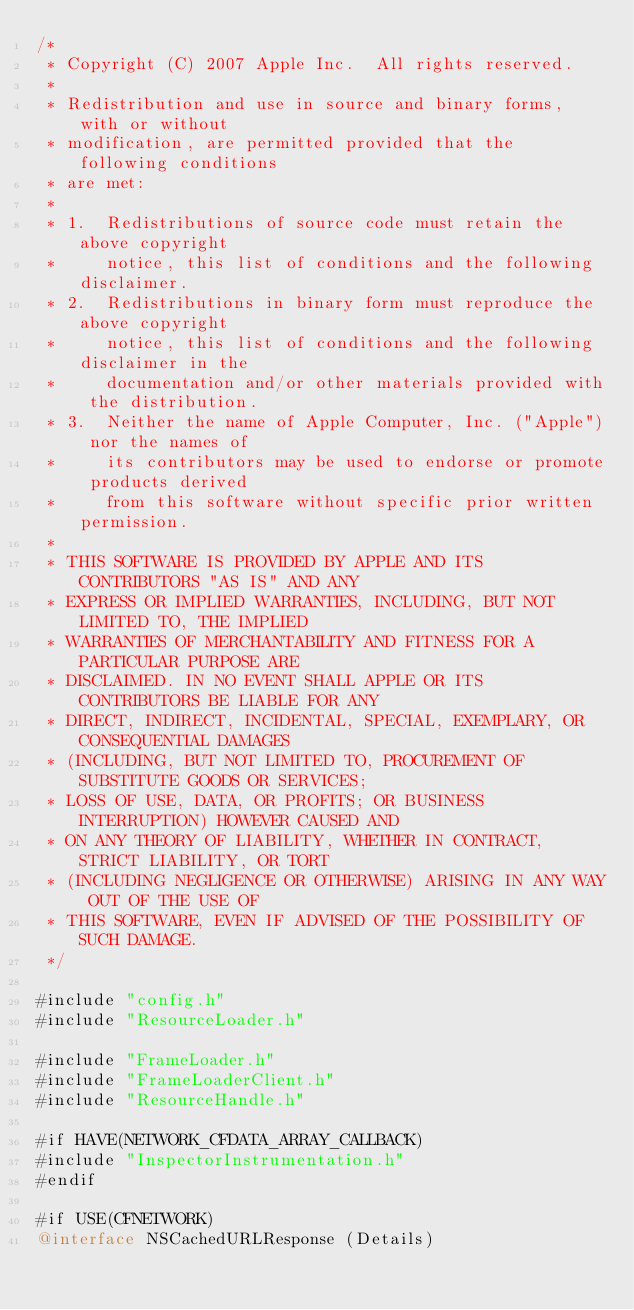Convert code to text. <code><loc_0><loc_0><loc_500><loc_500><_ObjectiveC_>/*
 * Copyright (C) 2007 Apple Inc.  All rights reserved.
 *
 * Redistribution and use in source and binary forms, with or without
 * modification, are permitted provided that the following conditions
 * are met:
 *
 * 1.  Redistributions of source code must retain the above copyright
 *     notice, this list of conditions and the following disclaimer. 
 * 2.  Redistributions in binary form must reproduce the above copyright
 *     notice, this list of conditions and the following disclaimer in the
 *     documentation and/or other materials provided with the distribution. 
 * 3.  Neither the name of Apple Computer, Inc. ("Apple") nor the names of
 *     its contributors may be used to endorse or promote products derived
 *     from this software without specific prior written permission. 
 *
 * THIS SOFTWARE IS PROVIDED BY APPLE AND ITS CONTRIBUTORS "AS IS" AND ANY
 * EXPRESS OR IMPLIED WARRANTIES, INCLUDING, BUT NOT LIMITED TO, THE IMPLIED
 * WARRANTIES OF MERCHANTABILITY AND FITNESS FOR A PARTICULAR PURPOSE ARE
 * DISCLAIMED. IN NO EVENT SHALL APPLE OR ITS CONTRIBUTORS BE LIABLE FOR ANY
 * DIRECT, INDIRECT, INCIDENTAL, SPECIAL, EXEMPLARY, OR CONSEQUENTIAL DAMAGES
 * (INCLUDING, BUT NOT LIMITED TO, PROCUREMENT OF SUBSTITUTE GOODS OR SERVICES;
 * LOSS OF USE, DATA, OR PROFITS; OR BUSINESS INTERRUPTION) HOWEVER CAUSED AND
 * ON ANY THEORY OF LIABILITY, WHETHER IN CONTRACT, STRICT LIABILITY, OR TORT
 * (INCLUDING NEGLIGENCE OR OTHERWISE) ARISING IN ANY WAY OUT OF THE USE OF
 * THIS SOFTWARE, EVEN IF ADVISED OF THE POSSIBILITY OF SUCH DAMAGE.
 */
 
#include "config.h"
#include "ResourceLoader.h"

#include "FrameLoader.h"
#include "FrameLoaderClient.h"
#include "ResourceHandle.h"

#if HAVE(NETWORK_CFDATA_ARRAY_CALLBACK)
#include "InspectorInstrumentation.h"
#endif

#if USE(CFNETWORK)
@interface NSCachedURLResponse (Details)</code> 